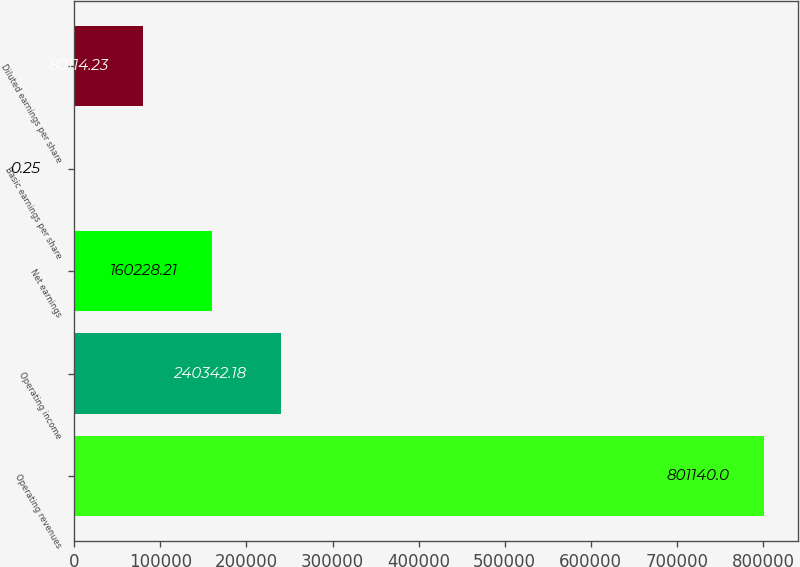Convert chart. <chart><loc_0><loc_0><loc_500><loc_500><bar_chart><fcel>Operating revenues<fcel>Operating income<fcel>Net earnings<fcel>Basic earnings per share<fcel>Diluted earnings per share<nl><fcel>801140<fcel>240342<fcel>160228<fcel>0.25<fcel>80114.2<nl></chart> 